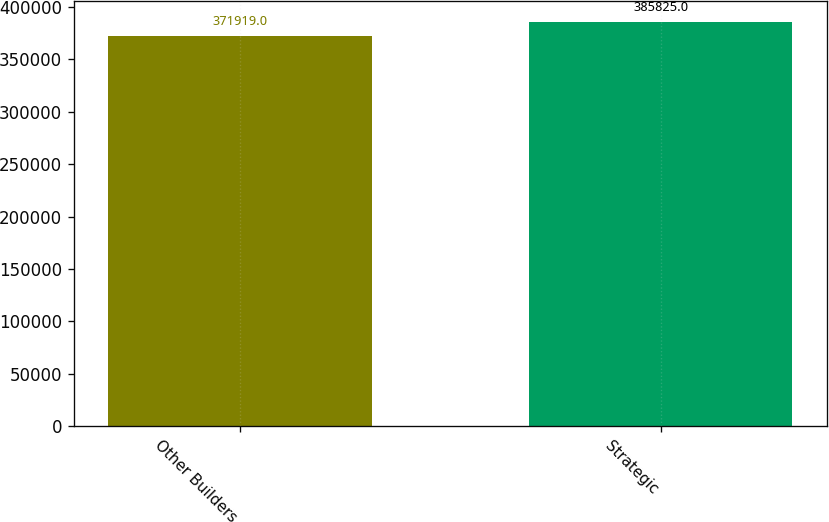Convert chart to OTSL. <chart><loc_0><loc_0><loc_500><loc_500><bar_chart><fcel>Other Builders<fcel>Strategic<nl><fcel>371919<fcel>385825<nl></chart> 